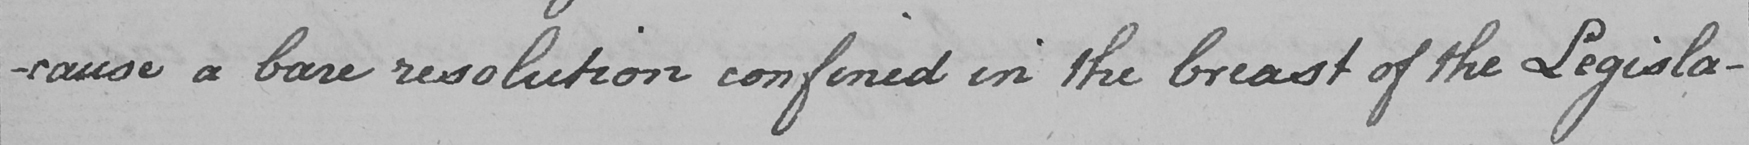What text is written in this handwritten line? -cause a bare resolution confined in the breast of the Legisla- 